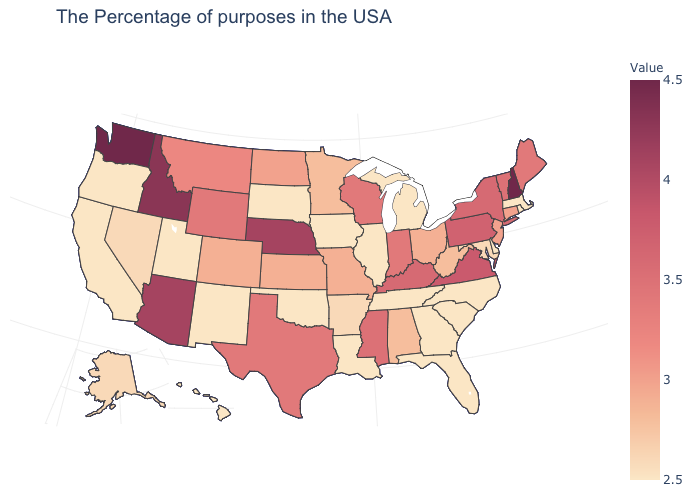Does the map have missing data?
Concise answer only. No. Does the map have missing data?
Keep it brief. No. Among the states that border Mississippi , which have the lowest value?
Write a very short answer. Tennessee, Louisiana. Does the map have missing data?
Quick response, please. No. Among the states that border Georgia , which have the highest value?
Quick response, please. Alabama. Which states hav the highest value in the MidWest?
Be succinct. Nebraska. Among the states that border California , which have the highest value?
Short answer required. Arizona. 